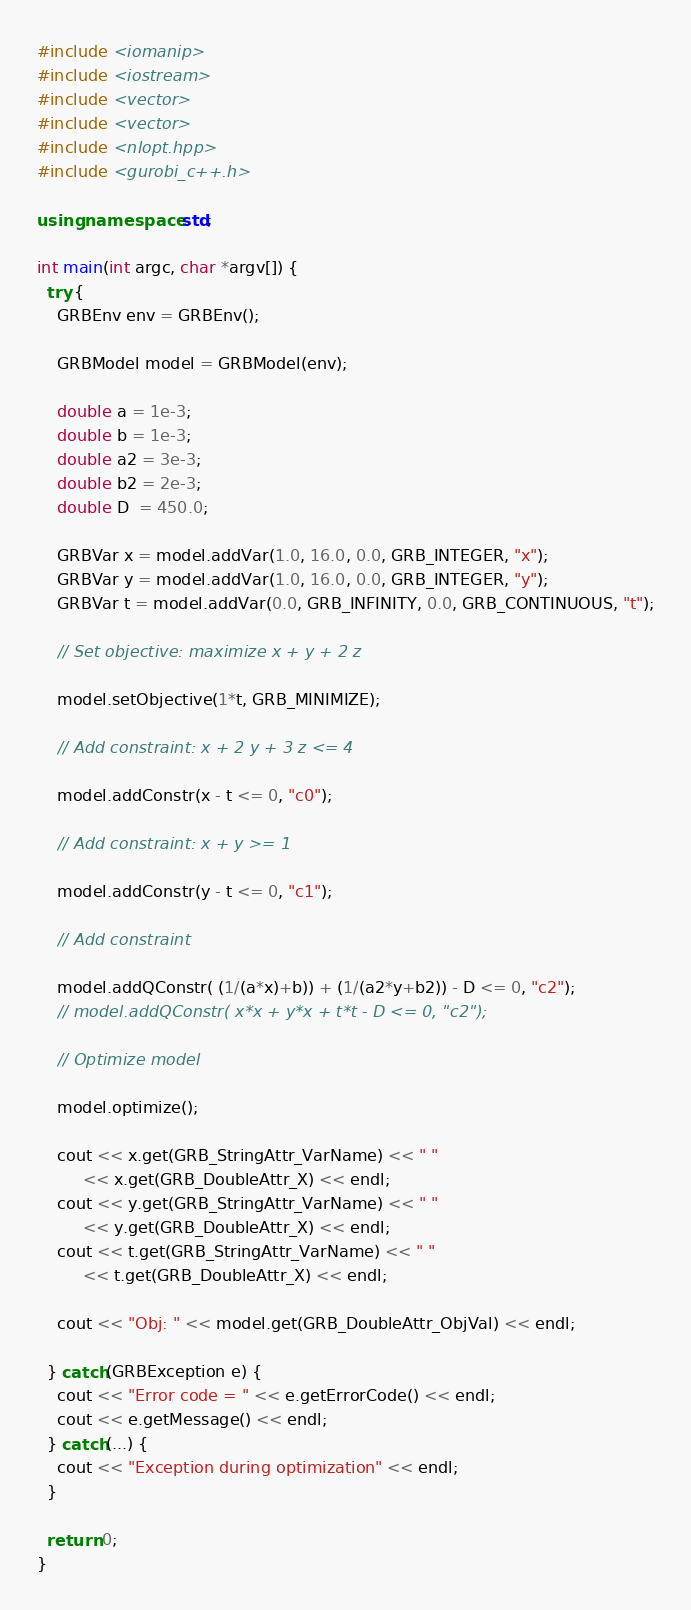<code> <loc_0><loc_0><loc_500><loc_500><_C++_>#include <iomanip>
#include <iostream>
#include <vector>
#include <vector>
#include <nlopt.hpp>
#include <gurobi_c++.h>

using namespace std;

int main(int argc, char *argv[]) {
  try {
    GRBEnv env = GRBEnv();

    GRBModel model = GRBModel(env);

    double a = 1e-3;
    double b = 1e-3;
    double a2 = 3e-3;
    double b2 = 2e-3;
    double D  = 450.0;

    GRBVar x = model.addVar(1.0, 16.0, 0.0, GRB_INTEGER, "x");
    GRBVar y = model.addVar(1.0, 16.0, 0.0, GRB_INTEGER, "y");
    GRBVar t = model.addVar(0.0, GRB_INFINITY, 0.0, GRB_CONTINUOUS, "t");

    // Set objective: maximize x + y + 2 z

    model.setObjective(1*t, GRB_MINIMIZE);

    // Add constraint: x + 2 y + 3 z <= 4

    model.addConstr(x - t <= 0, "c0");

    // Add constraint: x + y >= 1

    model.addConstr(y - t <= 0, "c1");

    // Add constraint

    model.addQConstr( (1/(a*x)+b)) + (1/(a2*y+b2)) - D <= 0, "c2");
    // model.addQConstr( x*x + y*x + t*t - D <= 0, "c2");

    // Optimize model

    model.optimize();

    cout << x.get(GRB_StringAttr_VarName) << " "
         << x.get(GRB_DoubleAttr_X) << endl;
    cout << y.get(GRB_StringAttr_VarName) << " "
         << y.get(GRB_DoubleAttr_X) << endl;
    cout << t.get(GRB_StringAttr_VarName) << " "
         << t.get(GRB_DoubleAttr_X) << endl;

    cout << "Obj: " << model.get(GRB_DoubleAttr_ObjVal) << endl;

  } catch(GRBException e) {
    cout << "Error code = " << e.getErrorCode() << endl;
    cout << e.getMessage() << endl;
  } catch(...) {
    cout << "Exception during optimization" << endl;
  }

  return 0;
}

</code> 